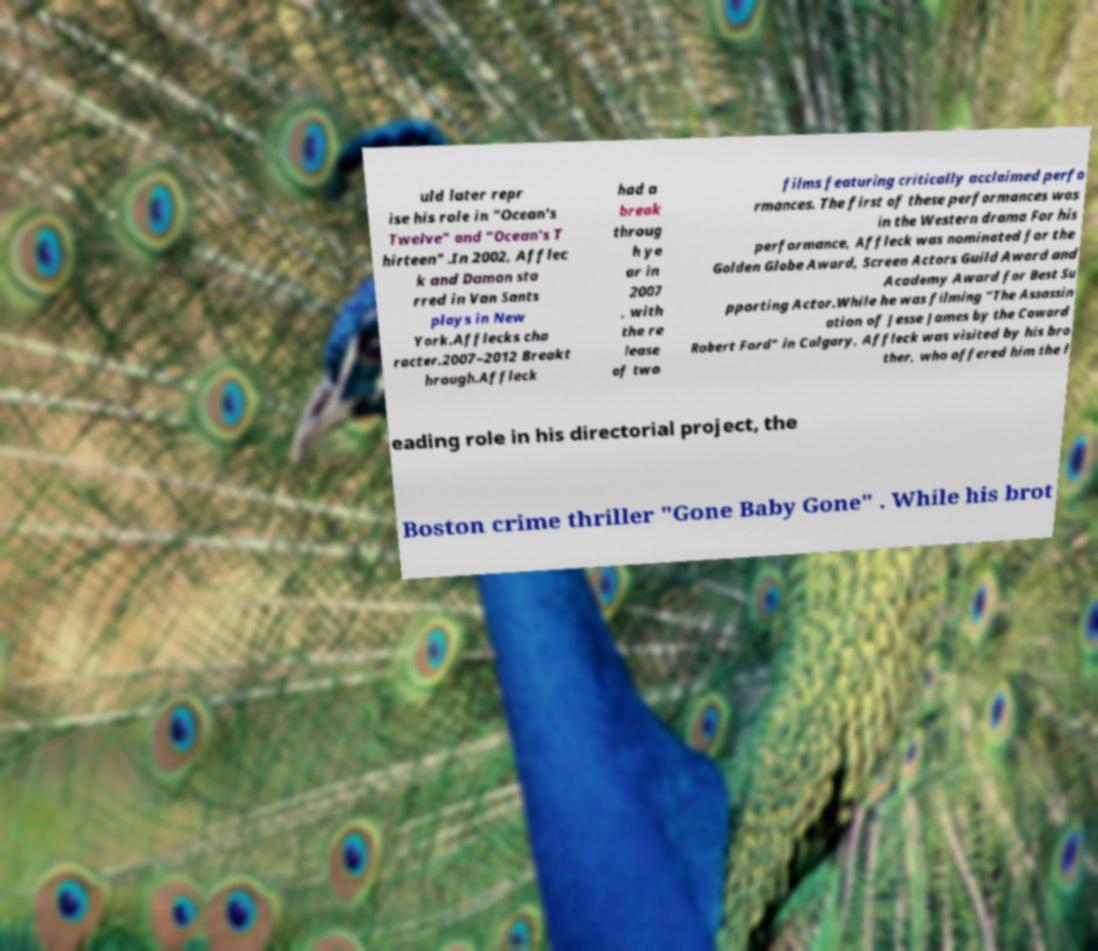What messages or text are displayed in this image? I need them in a readable, typed format. uld later repr ise his role in "Ocean's Twelve" and "Ocean's T hirteen" .In 2002, Afflec k and Damon sta rred in Van Sants plays in New York.Afflecks cha racter.2007–2012 Breakt hrough.Affleck had a break throug h ye ar in 2007 , with the re lease of two films featuring critically acclaimed perfo rmances. The first of these performances was in the Western drama For his performance, Affleck was nominated for the Golden Globe Award, Screen Actors Guild Award and Academy Award for Best Su pporting Actor.While he was filming "The Assassin ation of Jesse James by the Coward Robert Ford" in Calgary, Affleck was visited by his bro ther, who offered him the l eading role in his directorial project, the Boston crime thriller "Gone Baby Gone" . While his brot 